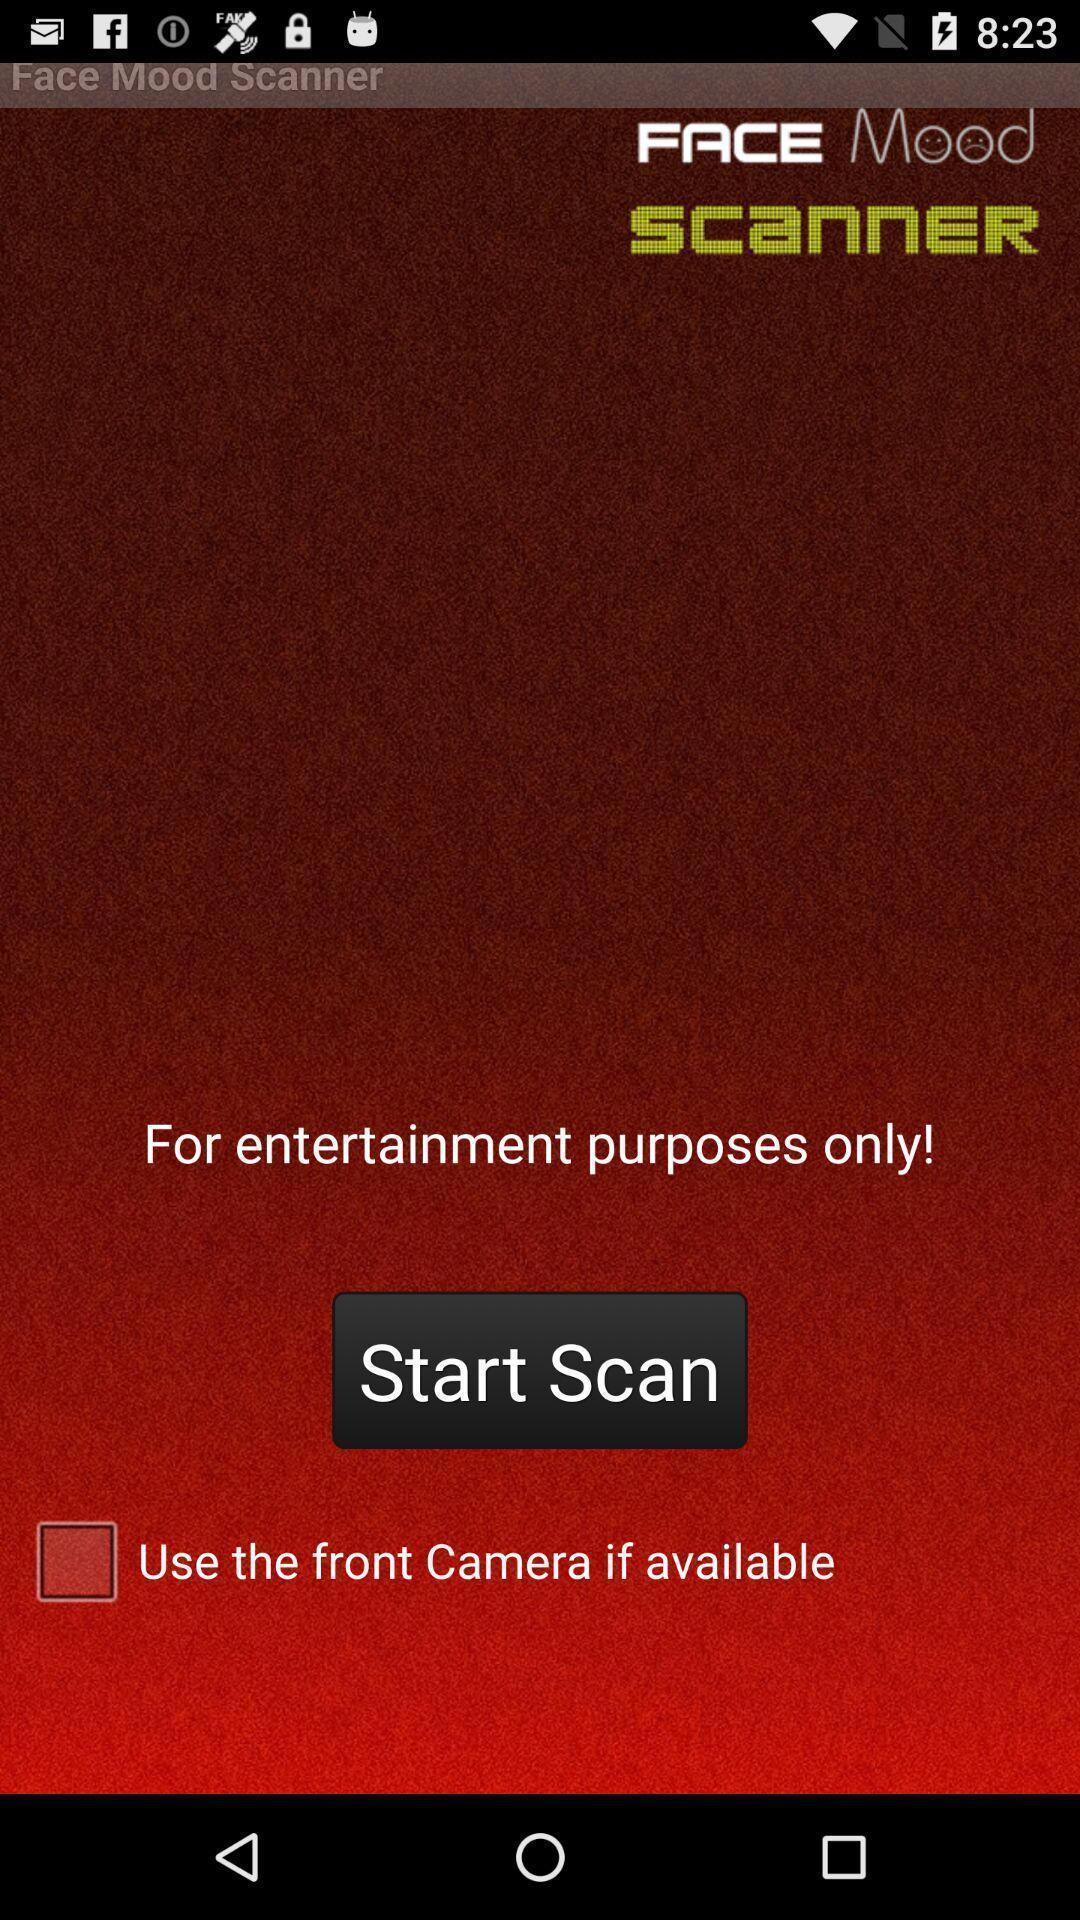Describe the key features of this screenshot. Welcome page. 